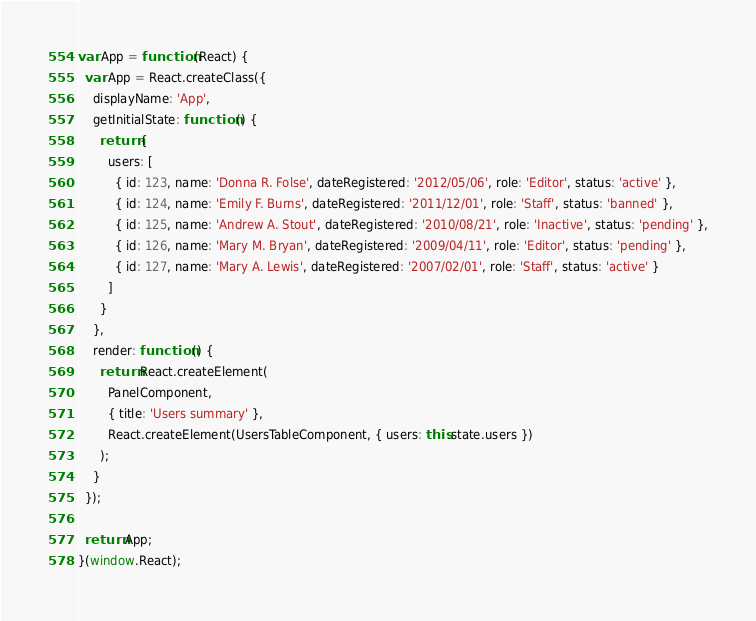Convert code to text. <code><loc_0><loc_0><loc_500><loc_500><_JavaScript_>var App = function (React) {
  var App = React.createClass({
    displayName: 'App',
    getInitialState: function () {
      return {
        users: [
          { id: 123, name: 'Donna R. Folse', dateRegistered: '2012/05/06', role: 'Editor', status: 'active' },
          { id: 124, name: 'Emily F. Burns', dateRegistered: '2011/12/01', role: 'Staff', status: 'banned' },
          { id: 125, name: 'Andrew A. Stout', dateRegistered: '2010/08/21', role: 'Inactive', status: 'pending' },
          { id: 126, name: 'Mary M. Bryan', dateRegistered: '2009/04/11', role: 'Editor', status: 'pending' },
          { id: 127, name: 'Mary A. Lewis', dateRegistered: '2007/02/01', role: 'Staff', status: 'active' }
        ]
      }
    },
    render: function () {
      return React.createElement(
        PanelComponent,
        { title: 'Users summary' },
        React.createElement(UsersTableComponent, { users: this.state.users })
      );
    }
  });

  return App;
}(window.React);
</code> 